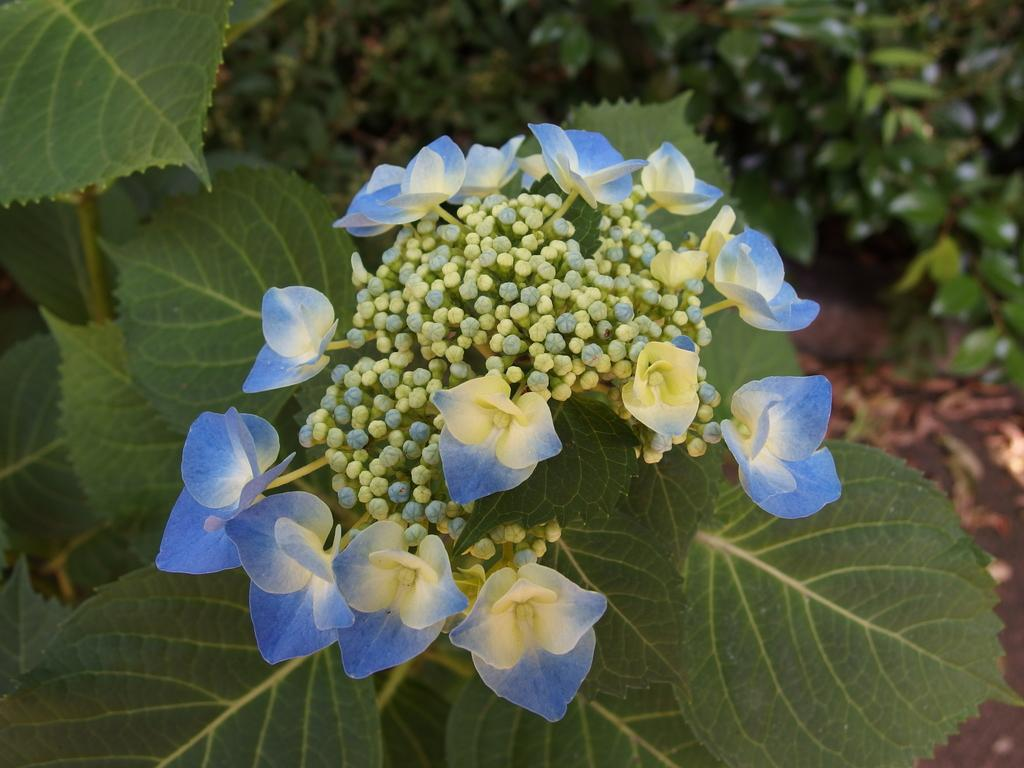What type of plants can be seen in the image? There are plants with flowers in the image. Where are the plants located in the image? The plants are at the side of the image. How many sisters are present in the image? There are no sisters present in the image; it features plants with flowers. What type of animal can be seen grazing in the image? There is no animal, such as a yak, present in the image. 